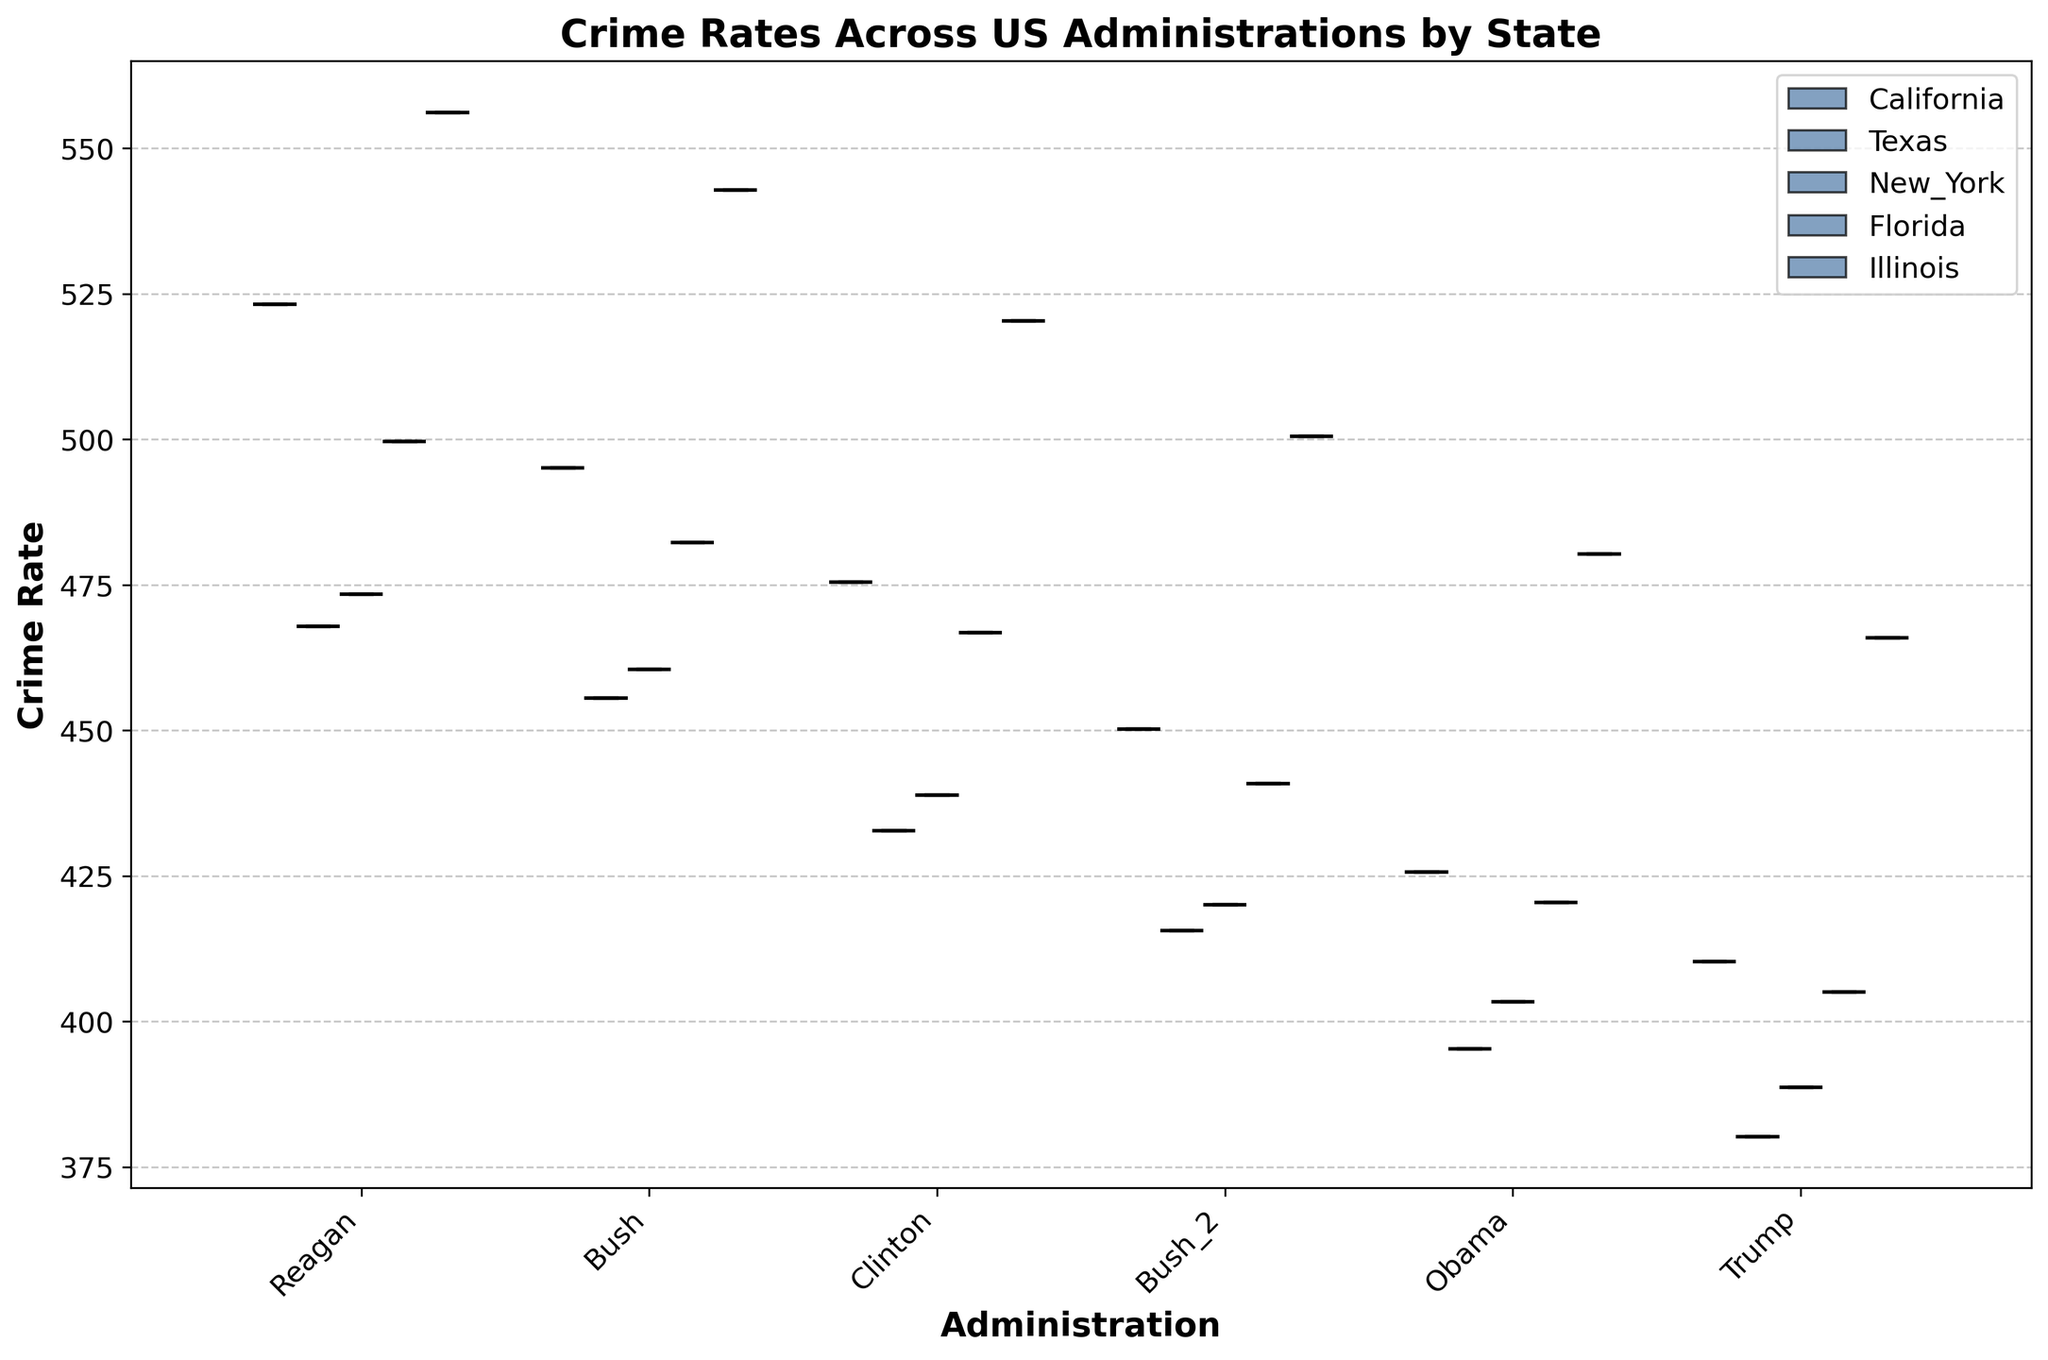What's the title of the figure? The title of a figure is usually located at the top of the plot and provides a concise summary of the visual information being displayed. In this case, the title is: "Crime Rates Across US Administrations by State"
Answer: Crime Rates Across US Administrations by State Which state has the highest crime rate under the Reagan administration? To determine which state has the highest crime rate under the Reagan administration, look for the highest boxplot under the Reagan group. Here, Illinois has the highest boxplot in the Reagan category.
Answer: Illinois How do crime rates trend in California across different administrations? Look at the boxplots for California across all administrations from Reagan to Trump. The heights of the boxplots reduce consistently, indicating a decreasing trend in crime rates over time for California.
Answer: Decreasing Which administration shows the lowest median crime rate across all states? To find the administration with the lowest median crime rate, look at the horizontal line inside each boxplot (the median) for each administration and compare. The Trump administration has the lowest median crime rate across all states.
Answer: Trump What is the difference between the highest crime rate in Illinois and the lowest crime rate in Texas under the Obama administration? First, identify the boxplot for Illinois under Obama and note its highest point. Then, identify the boxplot for Texas under Obama and note its lowest point. The highest point for Illinois is 480.3, and the lowest for Texas is 395.3. The difference is 480.3 - 395.3 = 85.
Answer: 85 Which state shows the most significant decrease in crime rates from Reagan to Trump? To find the most significant decrease, compare the height of the boxplots from Reagan to Trump for each state. Calculate the difference for each state and identify the largest value. California shows the greatest decrease from 523.2 (Reagan) to 410.3 (Trump), a difference of 112.9.
Answer: California How are the crime rates distributed in Florida during the Clinton administration? Look at the boxplot for Florida under the Clinton administration. The boxplot indicates the median, quartiles, and possible outliers. The median is in the middle of the box, with the upper and lower quartiles defining the interquartile range, and whiskers that may indicate variability.
Answer: Median around 466.8, IQR indicative of moderate variability Which state has more variability in crime rates under the Bush administration, Texas or New York? Variability in a boxplot is indicated by the interquartile range (the length of the box). Compare the box length of Texas and New York under the Bush administration. Texas has a shorter box compared to New York, indicating less variability.
Answer: New York Is there any state where the crime rates increased during any administrations? Evaluation requires looking at the boxplots sequentially for each state by administration and identifying if there is any increase in heights. From the data, although minor, Illinois's crime rate indeed increased slightly from Obama (480.3) to Trump (465.9).
Answer: Yes, Illinois Which administration had the least impact on reducing crime rates on average across all states? Compare the boxplots for each administration looking for the smallest overall decrease in crime rates. The Bush administration generally shows the smallest reduction compared to other administrations, with less visible reduction in boxplot heights.
Answer: Bush 